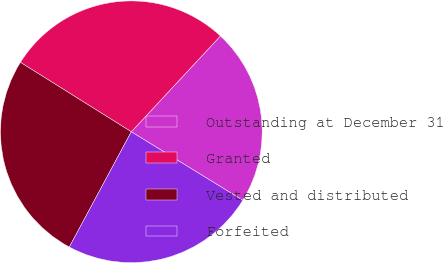Convert chart to OTSL. <chart><loc_0><loc_0><loc_500><loc_500><pie_chart><fcel>Outstanding at December 31<fcel>Granted<fcel>Vested and distributed<fcel>Forfeited<nl><fcel>21.84%<fcel>28.02%<fcel>26.05%<fcel>24.09%<nl></chart> 